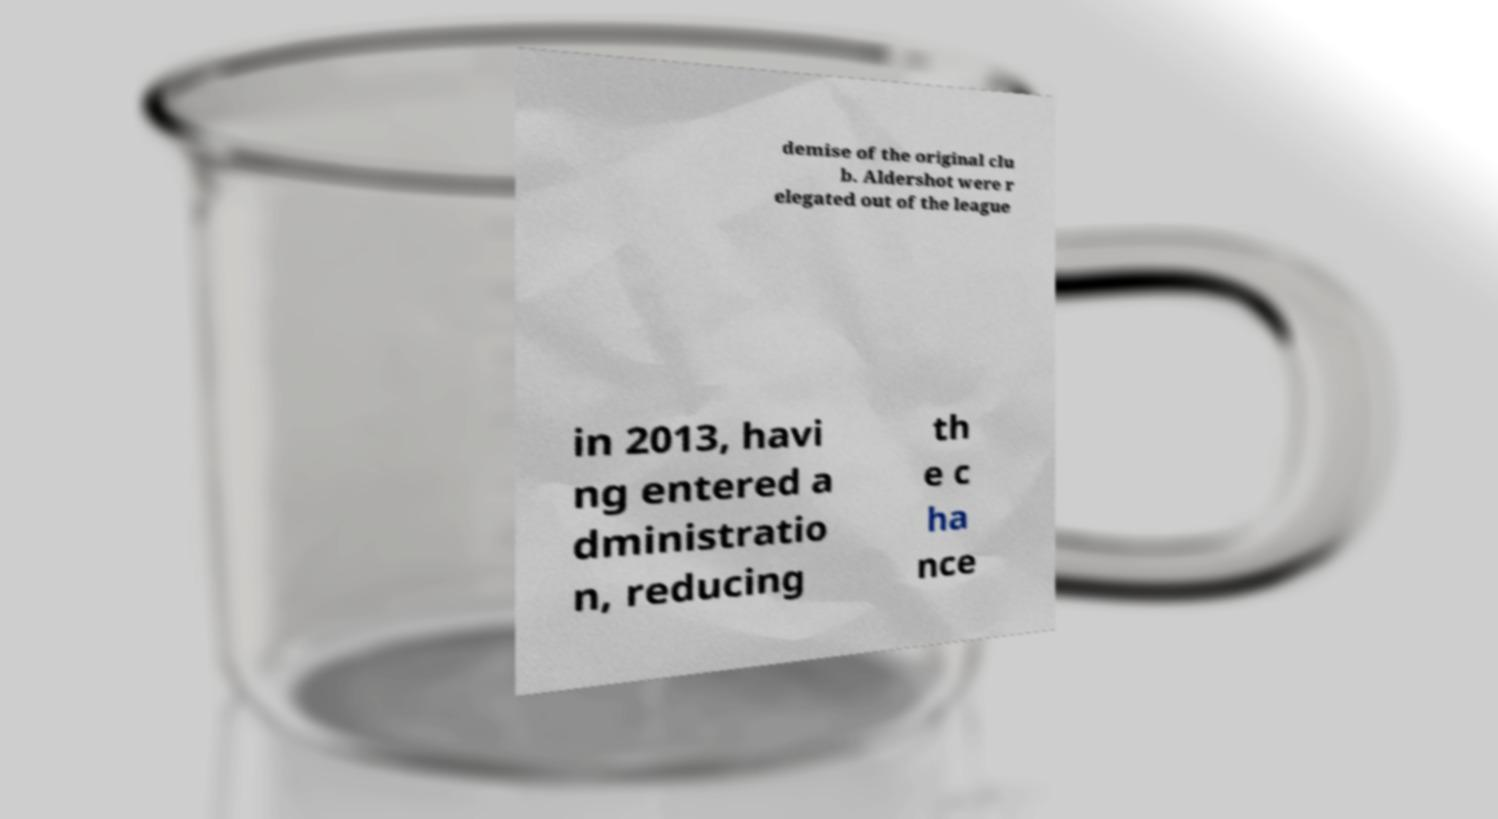For documentation purposes, I need the text within this image transcribed. Could you provide that? demise of the original clu b. Aldershot were r elegated out of the league in 2013, havi ng entered a dministratio n, reducing th e c ha nce 